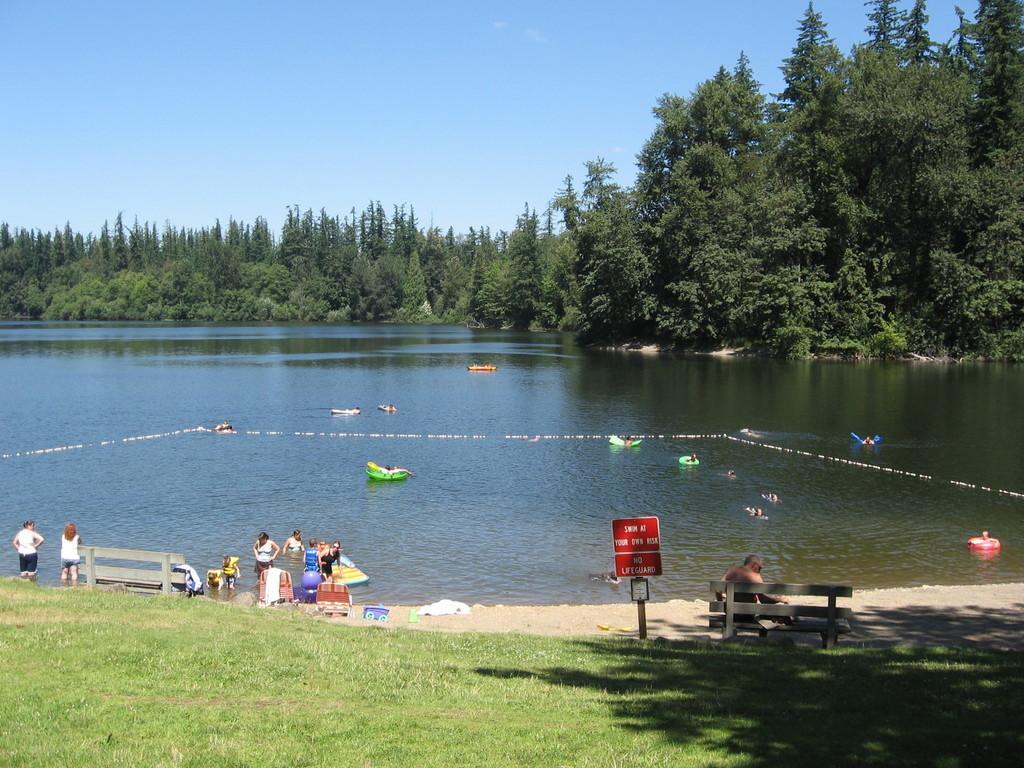How would you summarize this image in a sentence or two? In this image we can see a pound. Behind so many trees are there. The sky is in blue color. Bottom of the image, the land full of grass is there and benches are present. Near the pound, people are enjoying. 